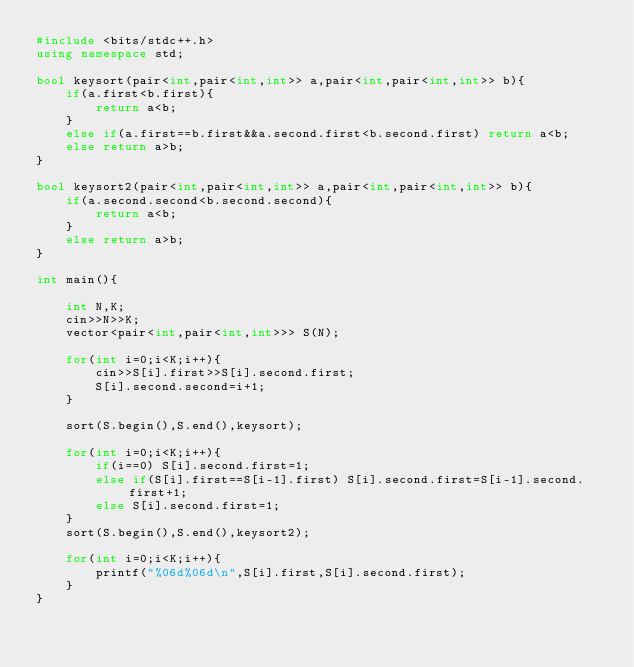<code> <loc_0><loc_0><loc_500><loc_500><_C++_>#include <bits/stdc++.h>
using namespace std;

bool keysort(pair<int,pair<int,int>> a,pair<int,pair<int,int>> b){
    if(a.first<b.first){
        return a<b;
    }
    else if(a.first==b.first&&a.second.first<b.second.first) return a<b;
    else return a>b;
}

bool keysort2(pair<int,pair<int,int>> a,pair<int,pair<int,int>> b){
    if(a.second.second<b.second.second){
        return a<b;
    }
    else return a>b;
}

int main(){
    
    int N,K;
    cin>>N>>K;
    vector<pair<int,pair<int,int>>> S(N);
    
    for(int i=0;i<K;i++){
        cin>>S[i].first>>S[i].second.first;
        S[i].second.second=i+1;
    }
    
    sort(S.begin(),S.end(),keysort);
   
    for(int i=0;i<K;i++){
        if(i==0) S[i].second.first=1;
        else if(S[i].first==S[i-1].first) S[i].second.first=S[i-1].second.first+1;
        else S[i].second.first=1;
    }
    sort(S.begin(),S.end(),keysort2);
    
    for(int i=0;i<K;i++){
        printf("%06d%06d\n",S[i].first,S[i].second.first);
    }
}
</code> 